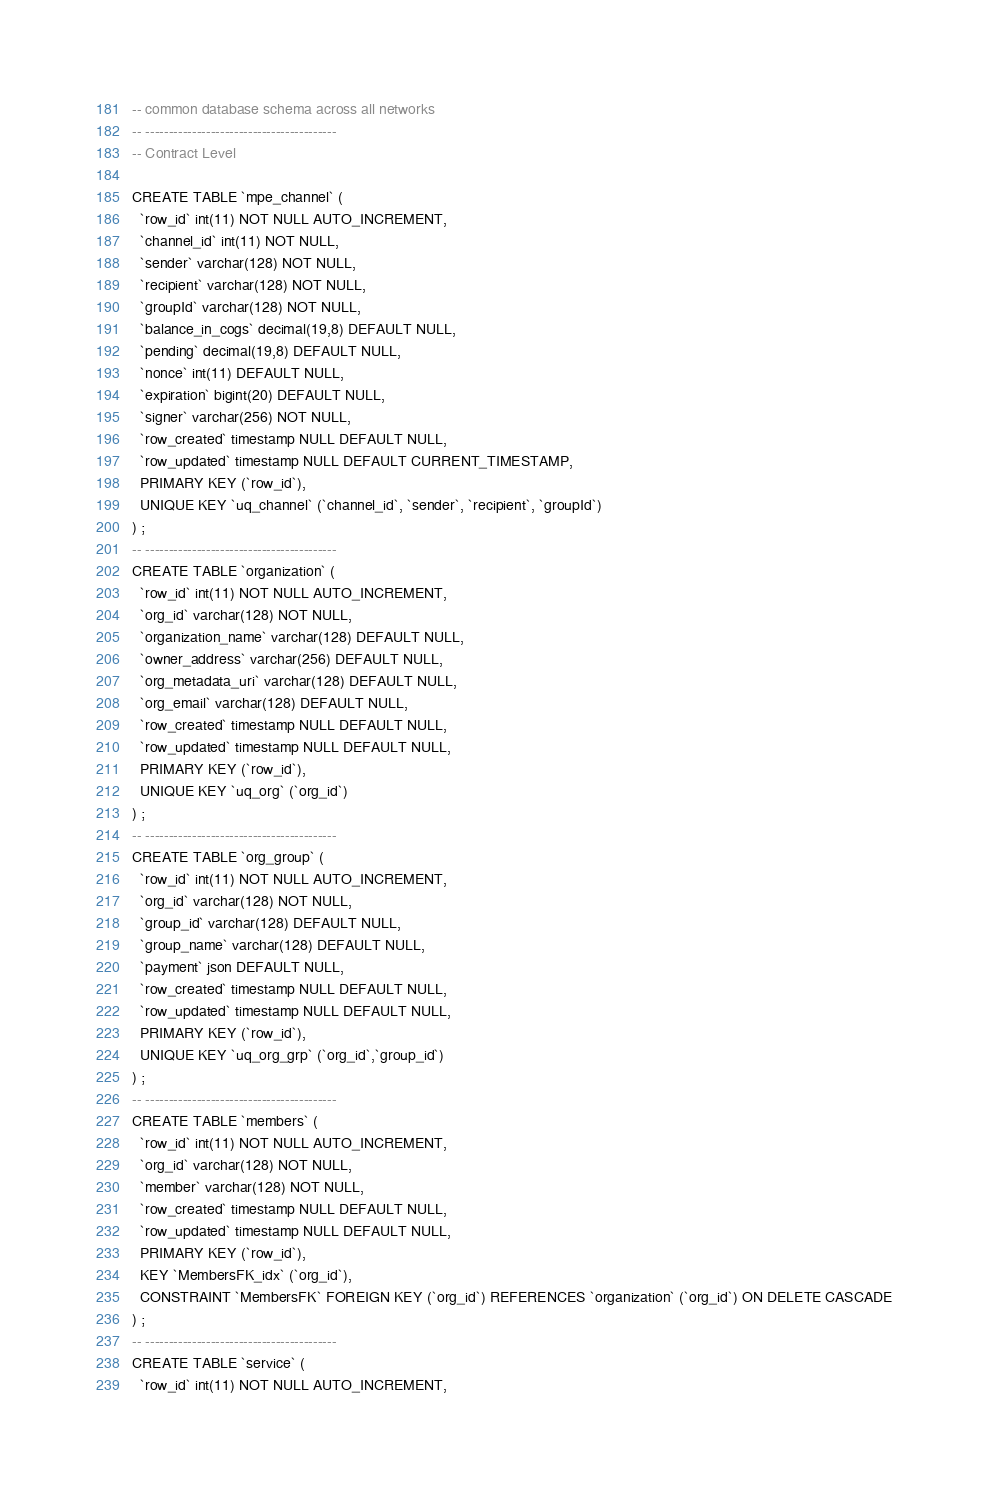<code> <loc_0><loc_0><loc_500><loc_500><_SQL_>-- common database schema across all networks
-- -----------------------------------------
-- Contract Level

CREATE TABLE `mpe_channel` (
  `row_id` int(11) NOT NULL AUTO_INCREMENT,
  `channel_id` int(11) NOT NULL,
  `sender` varchar(128) NOT NULL,
  `recipient` varchar(128) NOT NULL,
  `groupId` varchar(128) NOT NULL,
  `balance_in_cogs` decimal(19,8) DEFAULT NULL,
  `pending` decimal(19,8) DEFAULT NULL,
  `nonce` int(11) DEFAULT NULL,
  `expiration` bigint(20) DEFAULT NULL,
  `signer` varchar(256) NOT NULL,
  `row_created` timestamp NULL DEFAULT NULL,
  `row_updated` timestamp NULL DEFAULT CURRENT_TIMESTAMP,
  PRIMARY KEY (`row_id`),
  UNIQUE KEY `uq_channel` (`channel_id`, `sender`, `recipient`, `groupId`)
) ;
-- -----------------------------------------
CREATE TABLE `organization` (
  `row_id` int(11) NOT NULL AUTO_INCREMENT,
  `org_id` varchar(128) NOT NULL,
  `organization_name` varchar(128) DEFAULT NULL,
  `owner_address` varchar(256) DEFAULT NULL,
  `org_metadata_uri` varchar(128) DEFAULT NULL,
  `org_email` varchar(128) DEFAULT NULL,
  `row_created` timestamp NULL DEFAULT NULL,
  `row_updated` timestamp NULL DEFAULT NULL,
  PRIMARY KEY (`row_id`),
  UNIQUE KEY `uq_org` (`org_id`)
) ;
-- -----------------------------------------
CREATE TABLE `org_group` (
  `row_id` int(11) NOT NULL AUTO_INCREMENT,
  `org_id` varchar(128) NOT NULL,
  `group_id` varchar(128) DEFAULT NULL,
  `group_name` varchar(128) DEFAULT NULL,
  `payment` json DEFAULT NULL,
  `row_created` timestamp NULL DEFAULT NULL,
  `row_updated` timestamp NULL DEFAULT NULL,
  PRIMARY KEY (`row_id`),
  UNIQUE KEY `uq_org_grp` (`org_id`,`group_id`)
) ;
-- -----------------------------------------
CREATE TABLE `members` (
  `row_id` int(11) NOT NULL AUTO_INCREMENT,
  `org_id` varchar(128) NOT NULL,
  `member` varchar(128) NOT NULL,
  `row_created` timestamp NULL DEFAULT NULL,
  `row_updated` timestamp NULL DEFAULT NULL,
  PRIMARY KEY (`row_id`),
  KEY `MembersFK_idx` (`org_id`),
  CONSTRAINT `MembersFK` FOREIGN KEY (`org_id`) REFERENCES `organization` (`org_id`) ON DELETE CASCADE
) ;
-- -----------------------------------------
CREATE TABLE `service` (
  `row_id` int(11) NOT NULL AUTO_INCREMENT,</code> 